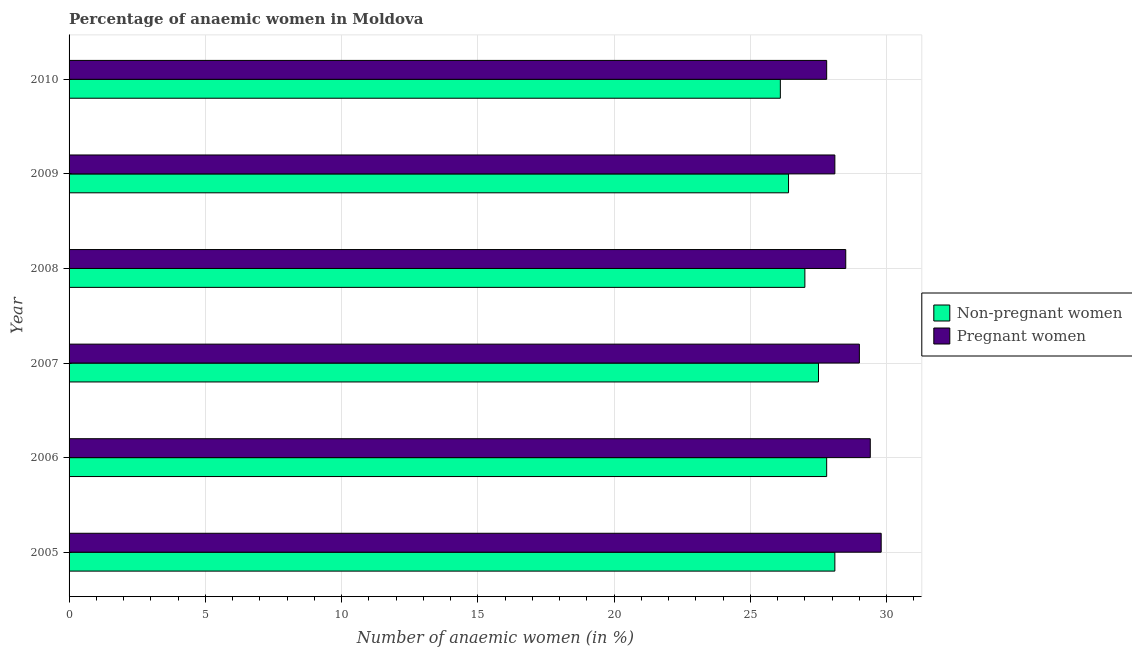How many different coloured bars are there?
Give a very brief answer. 2. Are the number of bars per tick equal to the number of legend labels?
Provide a short and direct response. Yes. How many bars are there on the 3rd tick from the top?
Provide a succinct answer. 2. How many bars are there on the 2nd tick from the bottom?
Offer a very short reply. 2. What is the label of the 5th group of bars from the top?
Give a very brief answer. 2006. In how many cases, is the number of bars for a given year not equal to the number of legend labels?
Your answer should be very brief. 0. What is the percentage of non-pregnant anaemic women in 2006?
Give a very brief answer. 27.8. Across all years, what is the maximum percentage of pregnant anaemic women?
Offer a terse response. 29.8. Across all years, what is the minimum percentage of non-pregnant anaemic women?
Your answer should be very brief. 26.1. In which year was the percentage of non-pregnant anaemic women maximum?
Your answer should be compact. 2005. In which year was the percentage of pregnant anaemic women minimum?
Offer a terse response. 2010. What is the total percentage of non-pregnant anaemic women in the graph?
Your answer should be compact. 162.9. What is the difference between the percentage of pregnant anaemic women in 2009 and that in 2010?
Provide a succinct answer. 0.3. What is the difference between the percentage of pregnant anaemic women in 2008 and the percentage of non-pregnant anaemic women in 2005?
Provide a short and direct response. 0.4. What is the average percentage of non-pregnant anaemic women per year?
Your response must be concise. 27.15. What is the ratio of the percentage of non-pregnant anaemic women in 2005 to that in 2009?
Your answer should be very brief. 1.06. What does the 2nd bar from the top in 2010 represents?
Ensure brevity in your answer.  Non-pregnant women. What does the 2nd bar from the bottom in 2008 represents?
Provide a succinct answer. Pregnant women. How many bars are there?
Your answer should be compact. 12. Are all the bars in the graph horizontal?
Make the answer very short. Yes. How many years are there in the graph?
Offer a very short reply. 6. What is the difference between two consecutive major ticks on the X-axis?
Provide a short and direct response. 5. Are the values on the major ticks of X-axis written in scientific E-notation?
Your answer should be very brief. No. Does the graph contain any zero values?
Offer a very short reply. No. Where does the legend appear in the graph?
Provide a succinct answer. Center right. How many legend labels are there?
Keep it short and to the point. 2. What is the title of the graph?
Keep it short and to the point. Percentage of anaemic women in Moldova. Does "Quality of trade" appear as one of the legend labels in the graph?
Provide a succinct answer. No. What is the label or title of the X-axis?
Your response must be concise. Number of anaemic women (in %). What is the label or title of the Y-axis?
Your answer should be very brief. Year. What is the Number of anaemic women (in %) in Non-pregnant women in 2005?
Your response must be concise. 28.1. What is the Number of anaemic women (in %) of Pregnant women in 2005?
Ensure brevity in your answer.  29.8. What is the Number of anaemic women (in %) of Non-pregnant women in 2006?
Provide a short and direct response. 27.8. What is the Number of anaemic women (in %) of Pregnant women in 2006?
Your response must be concise. 29.4. What is the Number of anaemic women (in %) of Pregnant women in 2008?
Your answer should be very brief. 28.5. What is the Number of anaemic women (in %) of Non-pregnant women in 2009?
Provide a succinct answer. 26.4. What is the Number of anaemic women (in %) in Pregnant women in 2009?
Ensure brevity in your answer.  28.1. What is the Number of anaemic women (in %) in Non-pregnant women in 2010?
Give a very brief answer. 26.1. What is the Number of anaemic women (in %) of Pregnant women in 2010?
Offer a very short reply. 27.8. Across all years, what is the maximum Number of anaemic women (in %) in Non-pregnant women?
Your answer should be compact. 28.1. Across all years, what is the maximum Number of anaemic women (in %) of Pregnant women?
Your answer should be very brief. 29.8. Across all years, what is the minimum Number of anaemic women (in %) of Non-pregnant women?
Your answer should be very brief. 26.1. Across all years, what is the minimum Number of anaemic women (in %) in Pregnant women?
Offer a very short reply. 27.8. What is the total Number of anaemic women (in %) of Non-pregnant women in the graph?
Your answer should be compact. 162.9. What is the total Number of anaemic women (in %) in Pregnant women in the graph?
Give a very brief answer. 172.6. What is the difference between the Number of anaemic women (in %) in Non-pregnant women in 2005 and that in 2007?
Your response must be concise. 0.6. What is the difference between the Number of anaemic women (in %) of Pregnant women in 2005 and that in 2007?
Your response must be concise. 0.8. What is the difference between the Number of anaemic women (in %) of Non-pregnant women in 2005 and that in 2008?
Make the answer very short. 1.1. What is the difference between the Number of anaemic women (in %) in Non-pregnant women in 2005 and that in 2009?
Offer a terse response. 1.7. What is the difference between the Number of anaemic women (in %) of Pregnant women in 2005 and that in 2009?
Your answer should be very brief. 1.7. What is the difference between the Number of anaemic women (in %) of Pregnant women in 2005 and that in 2010?
Keep it short and to the point. 2. What is the difference between the Number of anaemic women (in %) of Non-pregnant women in 2006 and that in 2007?
Your response must be concise. 0.3. What is the difference between the Number of anaemic women (in %) of Non-pregnant women in 2006 and that in 2008?
Your answer should be very brief. 0.8. What is the difference between the Number of anaemic women (in %) of Non-pregnant women in 2006 and that in 2009?
Keep it short and to the point. 1.4. What is the difference between the Number of anaemic women (in %) in Pregnant women in 2006 and that in 2009?
Your response must be concise. 1.3. What is the difference between the Number of anaemic women (in %) of Non-pregnant women in 2006 and that in 2010?
Your response must be concise. 1.7. What is the difference between the Number of anaemic women (in %) of Non-pregnant women in 2007 and that in 2008?
Offer a terse response. 0.5. What is the difference between the Number of anaemic women (in %) in Pregnant women in 2007 and that in 2008?
Offer a very short reply. 0.5. What is the difference between the Number of anaemic women (in %) of Non-pregnant women in 2007 and that in 2009?
Provide a succinct answer. 1.1. What is the difference between the Number of anaemic women (in %) in Non-pregnant women in 2007 and that in 2010?
Give a very brief answer. 1.4. What is the difference between the Number of anaemic women (in %) in Pregnant women in 2007 and that in 2010?
Ensure brevity in your answer.  1.2. What is the difference between the Number of anaemic women (in %) of Non-pregnant women in 2008 and that in 2010?
Give a very brief answer. 0.9. What is the difference between the Number of anaemic women (in %) of Non-pregnant women in 2005 and the Number of anaemic women (in %) of Pregnant women in 2008?
Provide a succinct answer. -0.4. What is the difference between the Number of anaemic women (in %) of Non-pregnant women in 2005 and the Number of anaemic women (in %) of Pregnant women in 2010?
Keep it short and to the point. 0.3. What is the difference between the Number of anaemic women (in %) in Non-pregnant women in 2006 and the Number of anaemic women (in %) in Pregnant women in 2007?
Provide a succinct answer. -1.2. What is the difference between the Number of anaemic women (in %) in Non-pregnant women in 2006 and the Number of anaemic women (in %) in Pregnant women in 2009?
Your response must be concise. -0.3. What is the average Number of anaemic women (in %) in Non-pregnant women per year?
Offer a terse response. 27.15. What is the average Number of anaemic women (in %) in Pregnant women per year?
Your response must be concise. 28.77. In the year 2005, what is the difference between the Number of anaemic women (in %) of Non-pregnant women and Number of anaemic women (in %) of Pregnant women?
Your answer should be compact. -1.7. In the year 2006, what is the difference between the Number of anaemic women (in %) of Non-pregnant women and Number of anaemic women (in %) of Pregnant women?
Offer a terse response. -1.6. In the year 2007, what is the difference between the Number of anaemic women (in %) of Non-pregnant women and Number of anaemic women (in %) of Pregnant women?
Give a very brief answer. -1.5. In the year 2008, what is the difference between the Number of anaemic women (in %) in Non-pregnant women and Number of anaemic women (in %) in Pregnant women?
Give a very brief answer. -1.5. In the year 2009, what is the difference between the Number of anaemic women (in %) in Non-pregnant women and Number of anaemic women (in %) in Pregnant women?
Your answer should be compact. -1.7. In the year 2010, what is the difference between the Number of anaemic women (in %) of Non-pregnant women and Number of anaemic women (in %) of Pregnant women?
Offer a very short reply. -1.7. What is the ratio of the Number of anaemic women (in %) in Non-pregnant women in 2005 to that in 2006?
Give a very brief answer. 1.01. What is the ratio of the Number of anaemic women (in %) of Pregnant women in 2005 to that in 2006?
Your response must be concise. 1.01. What is the ratio of the Number of anaemic women (in %) of Non-pregnant women in 2005 to that in 2007?
Offer a very short reply. 1.02. What is the ratio of the Number of anaemic women (in %) in Pregnant women in 2005 to that in 2007?
Your response must be concise. 1.03. What is the ratio of the Number of anaemic women (in %) in Non-pregnant women in 2005 to that in 2008?
Provide a short and direct response. 1.04. What is the ratio of the Number of anaemic women (in %) in Pregnant women in 2005 to that in 2008?
Your response must be concise. 1.05. What is the ratio of the Number of anaemic women (in %) in Non-pregnant women in 2005 to that in 2009?
Give a very brief answer. 1.06. What is the ratio of the Number of anaemic women (in %) in Pregnant women in 2005 to that in 2009?
Offer a terse response. 1.06. What is the ratio of the Number of anaemic women (in %) of Non-pregnant women in 2005 to that in 2010?
Your answer should be very brief. 1.08. What is the ratio of the Number of anaemic women (in %) in Pregnant women in 2005 to that in 2010?
Provide a short and direct response. 1.07. What is the ratio of the Number of anaemic women (in %) in Non-pregnant women in 2006 to that in 2007?
Provide a short and direct response. 1.01. What is the ratio of the Number of anaemic women (in %) in Pregnant women in 2006 to that in 2007?
Offer a very short reply. 1.01. What is the ratio of the Number of anaemic women (in %) of Non-pregnant women in 2006 to that in 2008?
Provide a succinct answer. 1.03. What is the ratio of the Number of anaemic women (in %) in Pregnant women in 2006 to that in 2008?
Ensure brevity in your answer.  1.03. What is the ratio of the Number of anaemic women (in %) in Non-pregnant women in 2006 to that in 2009?
Offer a terse response. 1.05. What is the ratio of the Number of anaemic women (in %) of Pregnant women in 2006 to that in 2009?
Make the answer very short. 1.05. What is the ratio of the Number of anaemic women (in %) in Non-pregnant women in 2006 to that in 2010?
Give a very brief answer. 1.07. What is the ratio of the Number of anaemic women (in %) in Pregnant women in 2006 to that in 2010?
Provide a succinct answer. 1.06. What is the ratio of the Number of anaemic women (in %) of Non-pregnant women in 2007 to that in 2008?
Provide a short and direct response. 1.02. What is the ratio of the Number of anaemic women (in %) of Pregnant women in 2007 to that in 2008?
Your response must be concise. 1.02. What is the ratio of the Number of anaemic women (in %) of Non-pregnant women in 2007 to that in 2009?
Give a very brief answer. 1.04. What is the ratio of the Number of anaemic women (in %) in Pregnant women in 2007 to that in 2009?
Your answer should be very brief. 1.03. What is the ratio of the Number of anaemic women (in %) of Non-pregnant women in 2007 to that in 2010?
Give a very brief answer. 1.05. What is the ratio of the Number of anaemic women (in %) in Pregnant women in 2007 to that in 2010?
Your response must be concise. 1.04. What is the ratio of the Number of anaemic women (in %) in Non-pregnant women in 2008 to that in 2009?
Keep it short and to the point. 1.02. What is the ratio of the Number of anaemic women (in %) in Pregnant women in 2008 to that in 2009?
Provide a succinct answer. 1.01. What is the ratio of the Number of anaemic women (in %) in Non-pregnant women in 2008 to that in 2010?
Make the answer very short. 1.03. What is the ratio of the Number of anaemic women (in %) in Pregnant women in 2008 to that in 2010?
Make the answer very short. 1.03. What is the ratio of the Number of anaemic women (in %) in Non-pregnant women in 2009 to that in 2010?
Ensure brevity in your answer.  1.01. What is the ratio of the Number of anaemic women (in %) in Pregnant women in 2009 to that in 2010?
Provide a short and direct response. 1.01. What is the difference between the highest and the lowest Number of anaemic women (in %) of Non-pregnant women?
Offer a terse response. 2. What is the difference between the highest and the lowest Number of anaemic women (in %) of Pregnant women?
Provide a short and direct response. 2. 